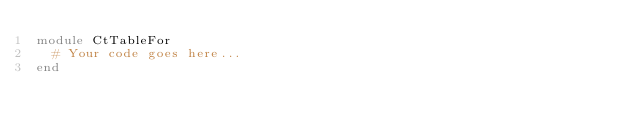Convert code to text. <code><loc_0><loc_0><loc_500><loc_500><_Ruby_>module CtTableFor
  # Your code goes here...
end
</code> 